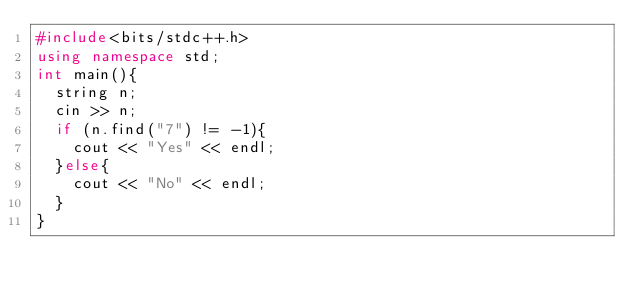<code> <loc_0><loc_0><loc_500><loc_500><_C++_>#include<bits/stdc++.h>
using namespace std;
int main(){
  string n;
  cin >> n;
  if (n.find("7") != -1){
    cout << "Yes" << endl;
  }else{
    cout << "No" << endl;
  }
}
</code> 